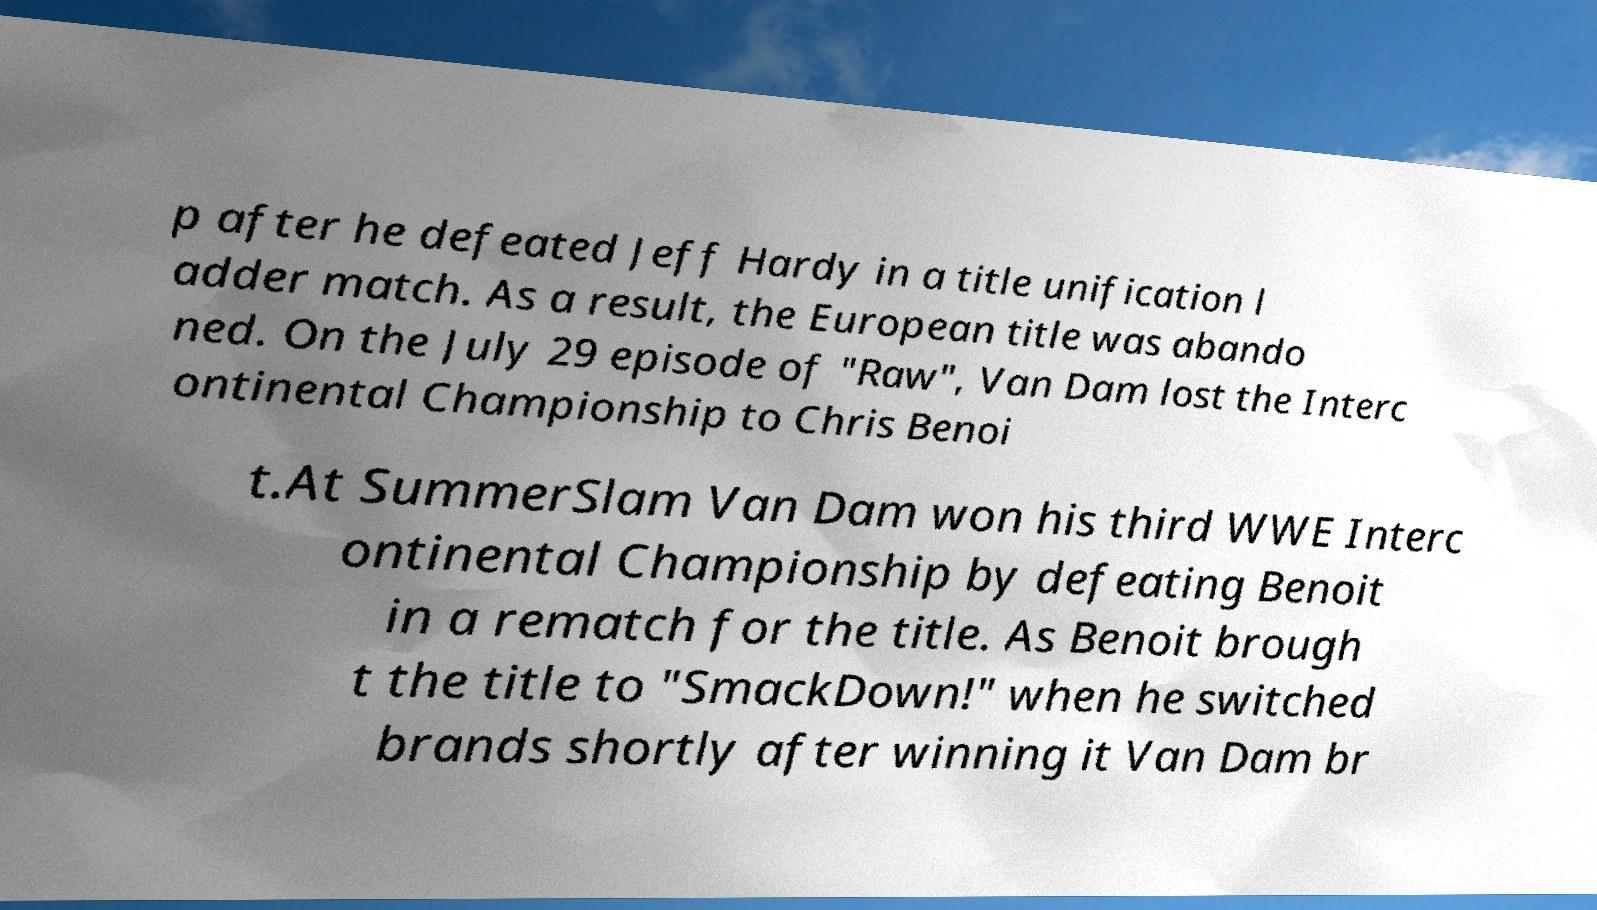For documentation purposes, I need the text within this image transcribed. Could you provide that? p after he defeated Jeff Hardy in a title unification l adder match. As a result, the European title was abando ned. On the July 29 episode of "Raw", Van Dam lost the Interc ontinental Championship to Chris Benoi t.At SummerSlam Van Dam won his third WWE Interc ontinental Championship by defeating Benoit in a rematch for the title. As Benoit brough t the title to "SmackDown!" when he switched brands shortly after winning it Van Dam br 